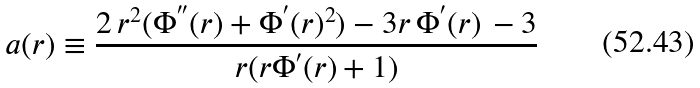Convert formula to latex. <formula><loc_0><loc_0><loc_500><loc_500>a ( r ) \equiv \frac { 2 \, { r } ^ { 2 } ( \Phi ^ { ^ { \prime \prime } } ( r ) + \Phi ^ { ^ { \prime } } ( r ) ^ { 2 } ) - 3 r \, \Phi ^ { ^ { \prime } } ( r ) \, - 3 } { r ( r \Phi ^ { ^ { \prime } } ( r ) + 1 ) }</formula> 